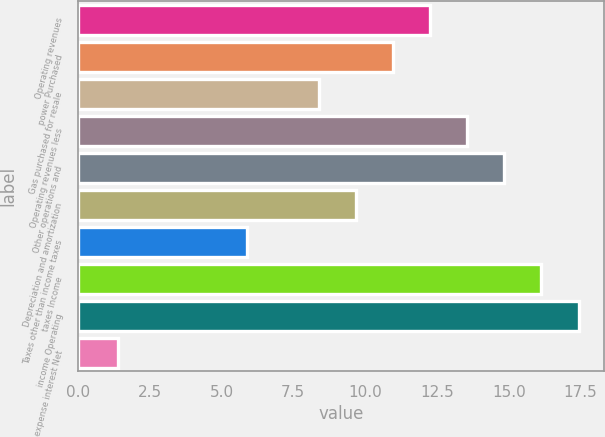Convert chart. <chart><loc_0><loc_0><loc_500><loc_500><bar_chart><fcel>Operating revenues<fcel>power Purchased<fcel>Gas purchased for resale<fcel>Operating revenues less<fcel>Other operations and<fcel>Depreciation and amortization<fcel>Taxes other than income taxes<fcel>taxes Income<fcel>income Operating<fcel>expense interest Net<nl><fcel>12.27<fcel>10.98<fcel>8.4<fcel>13.56<fcel>14.85<fcel>9.69<fcel>5.9<fcel>16.14<fcel>17.43<fcel>1.4<nl></chart> 